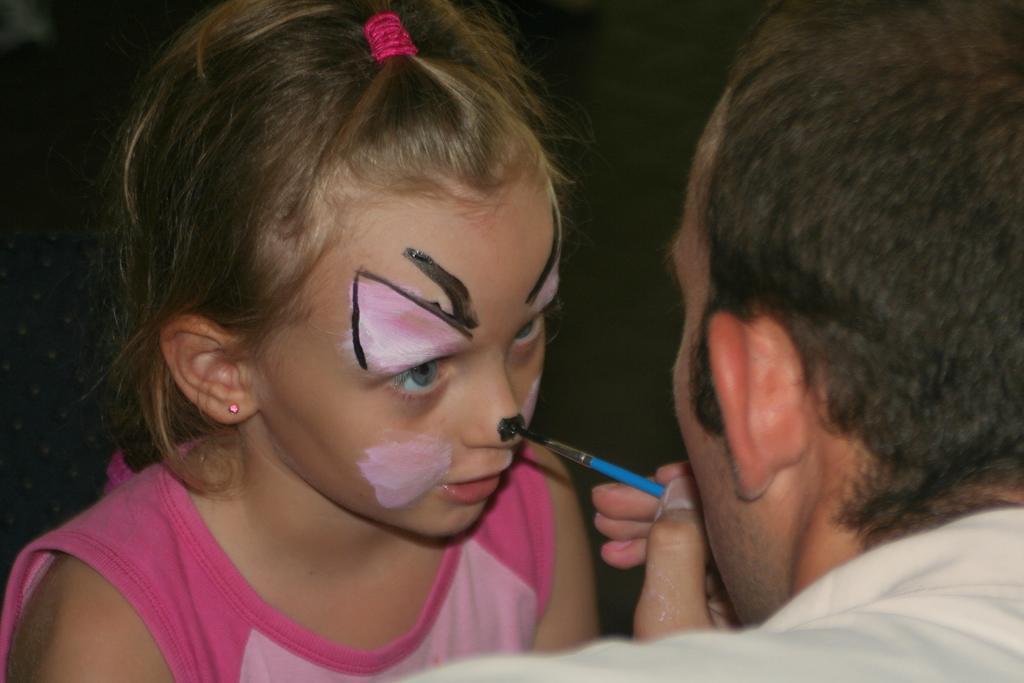In one or two sentences, can you explain what this image depicts? In this image there is a man towards the right of the image, he is holding a paint brush, there is a girl towards the bottom of the image, the background of the image is dark. 